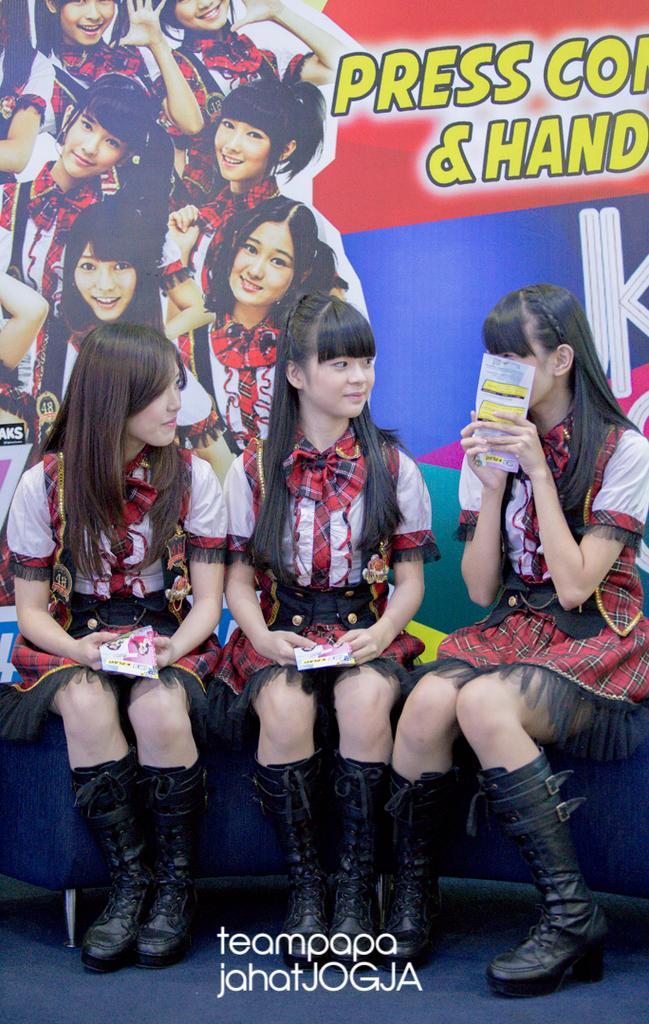Please provide a concise description of this image. Here we can see three persons are sitting on the sofa and they are holding books. In the background there is a banner. 